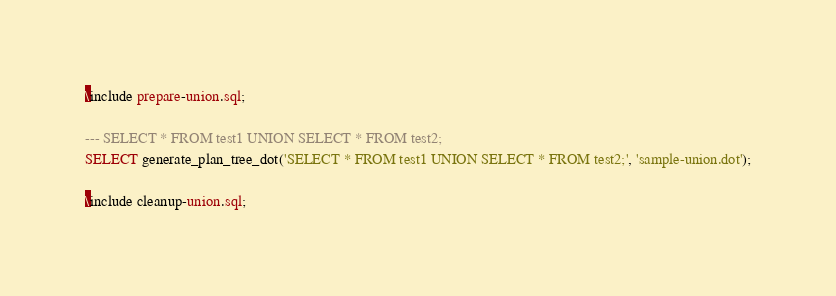Convert code to text. <code><loc_0><loc_0><loc_500><loc_500><_SQL_>\include prepare-union.sql;

--- SELECT * FROM test1 UNION SELECT * FROM test2;
SELECT generate_plan_tree_dot('SELECT * FROM test1 UNION SELECT * FROM test2;', 'sample-union.dot');

\include cleanup-union.sql;

</code> 